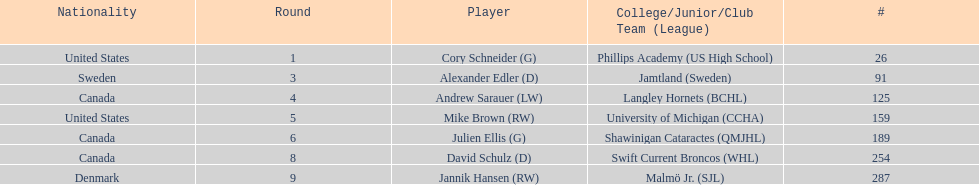What are the nationalities of the players? United States, Sweden, Canada, United States, Canada, Canada, Denmark. Of the players, which one lists his nationality as denmark? Jannik Hansen (RW). 